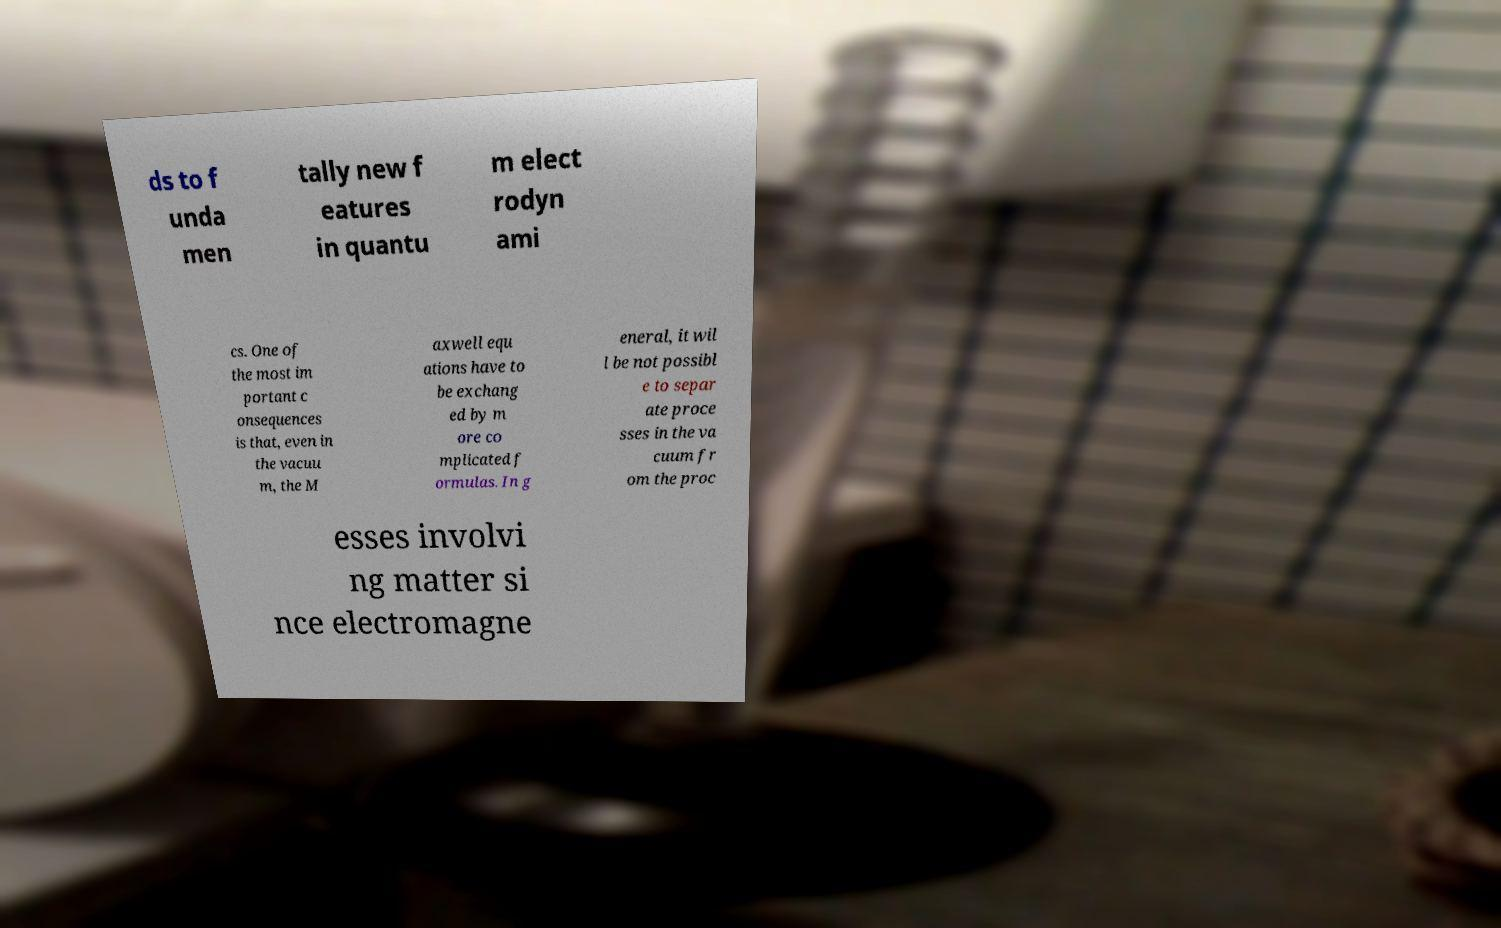Can you read and provide the text displayed in the image?This photo seems to have some interesting text. Can you extract and type it out for me? ds to f unda men tally new f eatures in quantu m elect rodyn ami cs. One of the most im portant c onsequences is that, even in the vacuu m, the M axwell equ ations have to be exchang ed by m ore co mplicated f ormulas. In g eneral, it wil l be not possibl e to separ ate proce sses in the va cuum fr om the proc esses involvi ng matter si nce electromagne 